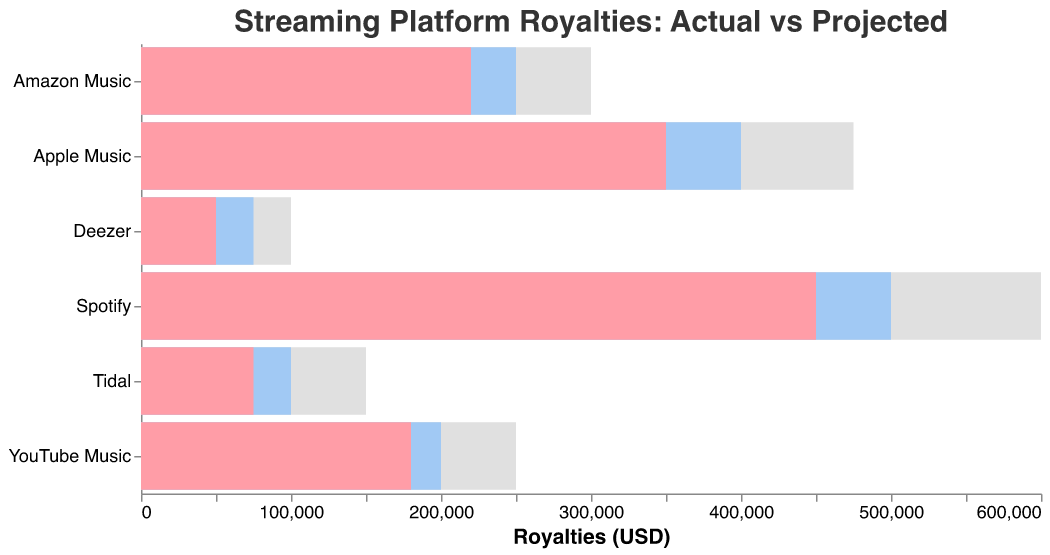What's the title of the chart? The title is displayed at the top of the chart and reads, "Streaming Platform Royalties: Actual vs Projected"
Answer: Streaming Platform Royalties: Actual vs Projected Which platform has the highest actual royalties? By examining the "Actual" bars, it is clear that Spotify has the highest actual royalties, represented by the largest bar in the "Actual" section
Answer: Spotify How much did Apple Music earn in projected royalties? Look at the bar for Apple Music in the "Projected" section, where the earnings are labeled
Answer: 400,000 What is the difference between actual and projected royalties for Tidal? Subtract the actual royalties from the projected royalties for Tidal: 100,000 - 75,000 = 25,000
Answer: 25,000 Which platform's actual earnings exceed its projected earnings? Compare the "Actual" bars to the "Projected" bars for each platform. None of the platforms have actual earnings exceeding their projected earnings
Answer: None How do the actual royalties for Amazon Music compare to YouTube Music? The actual royalties for Amazon Music are 220,000, while for YouTube Music, they are 180,000. Therefore, Amazon Music has higher actual royalties
Answer: Amazon Music What is the range of comparative earnings across all platforms? The lowest comparative earning is for Deezer at 100,000, and the highest is for Spotify at 600,000. Therefore, the range is 600,000 - 100,000 = 500,000
Answer: 500,000 Which platform has the closest actual earning to its projected earning? Calculate the absolute difference between actual and projected for each platform. Apple Music has the smallest difference: abs(350,000 - 400,000) = 50,000
Answer: Apple Music What can be inferred if the bar in the "Comparative" section is the longest? If the "Comparative" bar is the longest, it indicates that this platform has the highest comparative potential earnings, which likely sets it as the benchmark for other platforms. For example, Spotify
Answer: The platform has the highest comparative potential earnings 